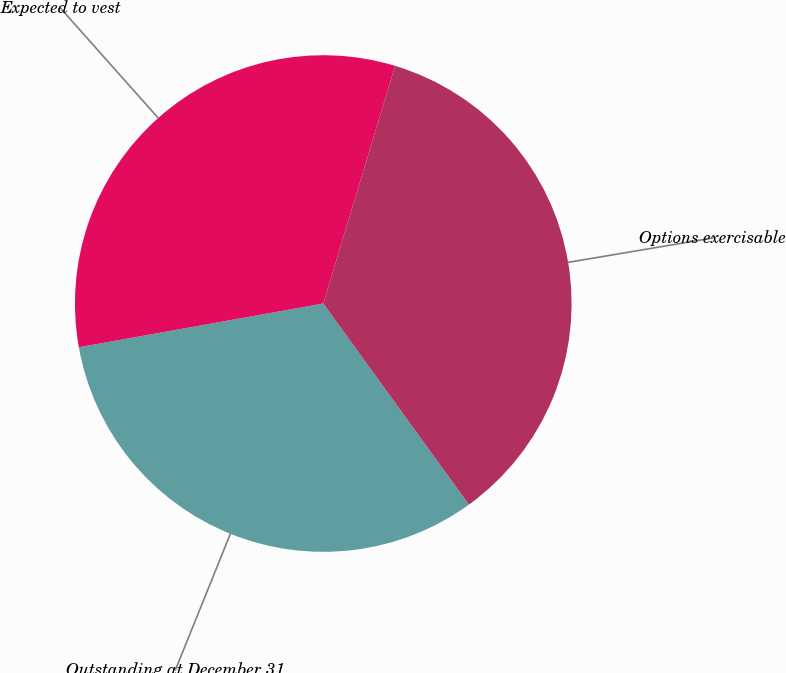Convert chart. <chart><loc_0><loc_0><loc_500><loc_500><pie_chart><fcel>Outstanding at December 31<fcel>Expected to vest<fcel>Options exercisable<nl><fcel>32.16%<fcel>32.49%<fcel>35.35%<nl></chart> 